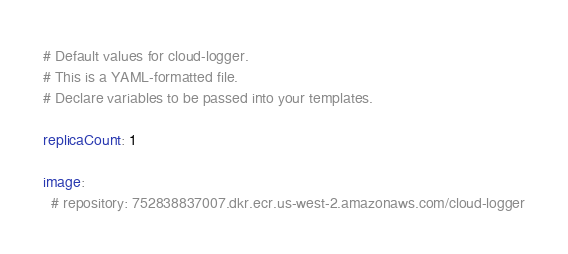<code> <loc_0><loc_0><loc_500><loc_500><_YAML_># Default values for cloud-logger.
# This is a YAML-formatted file.
# Declare variables to be passed into your templates.

replicaCount: 1

image:
  # repository: 752838837007.dkr.ecr.us-west-2.amazonaws.com/cloud-logger</code> 